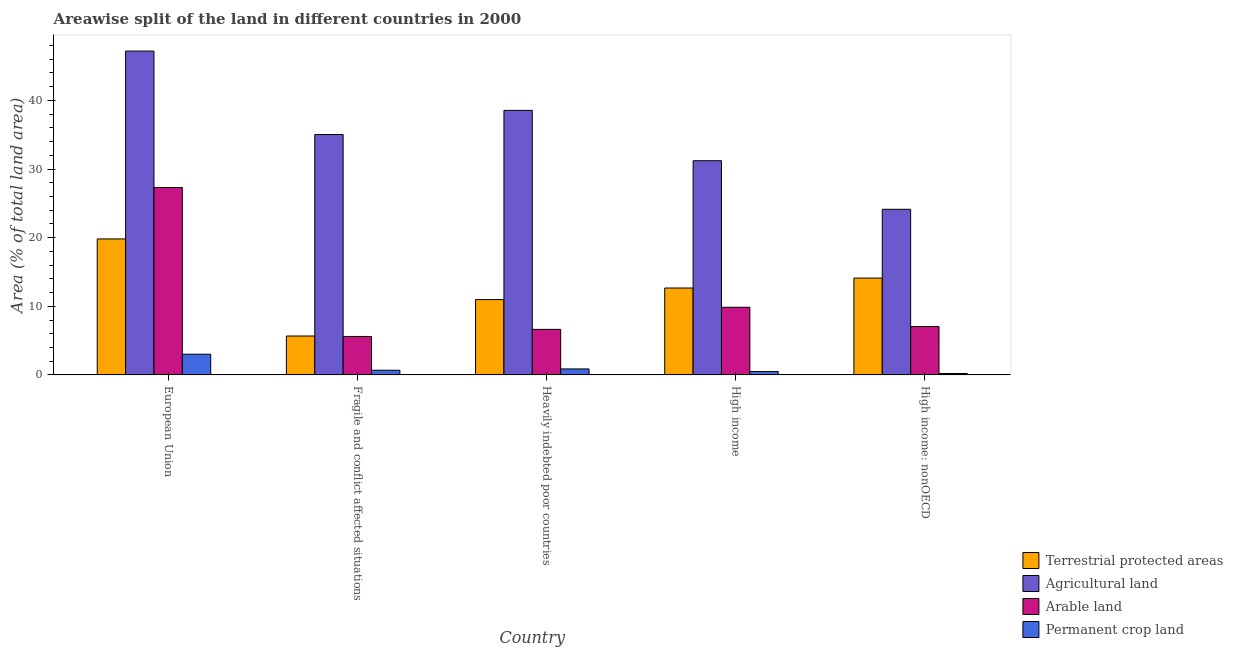How many different coloured bars are there?
Ensure brevity in your answer.  4. Are the number of bars per tick equal to the number of legend labels?
Give a very brief answer. Yes. How many bars are there on the 4th tick from the left?
Provide a succinct answer. 4. How many bars are there on the 3rd tick from the right?
Provide a succinct answer. 4. What is the percentage of area under agricultural land in European Union?
Offer a terse response. 47.19. Across all countries, what is the maximum percentage of area under agricultural land?
Provide a succinct answer. 47.19. Across all countries, what is the minimum percentage of area under permanent crop land?
Ensure brevity in your answer.  0.21. In which country was the percentage of land under terrestrial protection maximum?
Your answer should be very brief. European Union. In which country was the percentage of area under arable land minimum?
Offer a terse response. Fragile and conflict affected situations. What is the total percentage of land under terrestrial protection in the graph?
Provide a short and direct response. 63.24. What is the difference between the percentage of land under terrestrial protection in European Union and that in High income?
Offer a terse response. 7.15. What is the difference between the percentage of area under arable land in European Union and the percentage of land under terrestrial protection in High income?
Your response must be concise. 14.64. What is the average percentage of area under permanent crop land per country?
Make the answer very short. 1.05. What is the difference between the percentage of area under arable land and percentage of area under permanent crop land in Heavily indebted poor countries?
Your answer should be compact. 5.76. What is the ratio of the percentage of area under agricultural land in European Union to that in High income: nonOECD?
Give a very brief answer. 1.96. Is the difference between the percentage of area under permanent crop land in Heavily indebted poor countries and High income greater than the difference between the percentage of land under terrestrial protection in Heavily indebted poor countries and High income?
Your response must be concise. Yes. What is the difference between the highest and the second highest percentage of area under agricultural land?
Keep it short and to the point. 8.64. What is the difference between the highest and the lowest percentage of area under arable land?
Your answer should be compact. 21.71. In how many countries, is the percentage of area under arable land greater than the average percentage of area under arable land taken over all countries?
Your answer should be compact. 1. What does the 4th bar from the left in Fragile and conflict affected situations represents?
Your answer should be compact. Permanent crop land. What does the 2nd bar from the right in High income represents?
Give a very brief answer. Arable land. Is it the case that in every country, the sum of the percentage of land under terrestrial protection and percentage of area under agricultural land is greater than the percentage of area under arable land?
Provide a succinct answer. Yes. Are all the bars in the graph horizontal?
Make the answer very short. No. Are the values on the major ticks of Y-axis written in scientific E-notation?
Your response must be concise. No. Does the graph contain grids?
Your response must be concise. No. How many legend labels are there?
Make the answer very short. 4. What is the title of the graph?
Provide a succinct answer. Areawise split of the land in different countries in 2000. Does "International Development Association" appear as one of the legend labels in the graph?
Provide a succinct answer. No. What is the label or title of the X-axis?
Give a very brief answer. Country. What is the label or title of the Y-axis?
Your response must be concise. Area (% of total land area). What is the Area (% of total land area) of Terrestrial protected areas in European Union?
Offer a terse response. 19.81. What is the Area (% of total land area) in Agricultural land in European Union?
Keep it short and to the point. 47.19. What is the Area (% of total land area) of Arable land in European Union?
Your response must be concise. 27.31. What is the Area (% of total land area) in Permanent crop land in European Union?
Provide a succinct answer. 3.02. What is the Area (% of total land area) of Terrestrial protected areas in Fragile and conflict affected situations?
Your answer should be compact. 5.67. What is the Area (% of total land area) of Agricultural land in Fragile and conflict affected situations?
Keep it short and to the point. 35.03. What is the Area (% of total land area) in Arable land in Fragile and conflict affected situations?
Your answer should be compact. 5.6. What is the Area (% of total land area) of Permanent crop land in Fragile and conflict affected situations?
Give a very brief answer. 0.68. What is the Area (% of total land area) of Terrestrial protected areas in Heavily indebted poor countries?
Give a very brief answer. 10.98. What is the Area (% of total land area) in Agricultural land in Heavily indebted poor countries?
Your answer should be compact. 38.55. What is the Area (% of total land area) in Arable land in Heavily indebted poor countries?
Offer a terse response. 6.64. What is the Area (% of total land area) of Permanent crop land in Heavily indebted poor countries?
Give a very brief answer. 0.87. What is the Area (% of total land area) of Terrestrial protected areas in High income?
Provide a succinct answer. 12.67. What is the Area (% of total land area) in Agricultural land in High income?
Your answer should be compact. 31.21. What is the Area (% of total land area) of Arable land in High income?
Offer a very short reply. 9.86. What is the Area (% of total land area) of Permanent crop land in High income?
Make the answer very short. 0.5. What is the Area (% of total land area) of Terrestrial protected areas in High income: nonOECD?
Your answer should be compact. 14.11. What is the Area (% of total land area) of Agricultural land in High income: nonOECD?
Your response must be concise. 24.14. What is the Area (% of total land area) of Arable land in High income: nonOECD?
Offer a terse response. 7.05. What is the Area (% of total land area) in Permanent crop land in High income: nonOECD?
Your answer should be compact. 0.21. Across all countries, what is the maximum Area (% of total land area) of Terrestrial protected areas?
Your answer should be very brief. 19.81. Across all countries, what is the maximum Area (% of total land area) of Agricultural land?
Your answer should be very brief. 47.19. Across all countries, what is the maximum Area (% of total land area) of Arable land?
Provide a succinct answer. 27.31. Across all countries, what is the maximum Area (% of total land area) in Permanent crop land?
Make the answer very short. 3.02. Across all countries, what is the minimum Area (% of total land area) in Terrestrial protected areas?
Offer a terse response. 5.67. Across all countries, what is the minimum Area (% of total land area) of Agricultural land?
Provide a short and direct response. 24.14. Across all countries, what is the minimum Area (% of total land area) in Arable land?
Your response must be concise. 5.6. Across all countries, what is the minimum Area (% of total land area) in Permanent crop land?
Your response must be concise. 0.21. What is the total Area (% of total land area) in Terrestrial protected areas in the graph?
Your answer should be compact. 63.24. What is the total Area (% of total land area) of Agricultural land in the graph?
Offer a terse response. 176.12. What is the total Area (% of total land area) of Arable land in the graph?
Make the answer very short. 56.45. What is the total Area (% of total land area) of Permanent crop land in the graph?
Your response must be concise. 5.27. What is the difference between the Area (% of total land area) in Terrestrial protected areas in European Union and that in Fragile and conflict affected situations?
Your answer should be very brief. 14.14. What is the difference between the Area (% of total land area) in Agricultural land in European Union and that in Fragile and conflict affected situations?
Make the answer very short. 12.17. What is the difference between the Area (% of total land area) of Arable land in European Union and that in Fragile and conflict affected situations?
Keep it short and to the point. 21.71. What is the difference between the Area (% of total land area) in Permanent crop land in European Union and that in Fragile and conflict affected situations?
Give a very brief answer. 2.33. What is the difference between the Area (% of total land area) of Terrestrial protected areas in European Union and that in Heavily indebted poor countries?
Ensure brevity in your answer.  8.83. What is the difference between the Area (% of total land area) of Agricultural land in European Union and that in Heavily indebted poor countries?
Give a very brief answer. 8.64. What is the difference between the Area (% of total land area) of Arable land in European Union and that in Heavily indebted poor countries?
Offer a terse response. 20.67. What is the difference between the Area (% of total land area) of Permanent crop land in European Union and that in Heavily indebted poor countries?
Offer a very short reply. 2.14. What is the difference between the Area (% of total land area) of Terrestrial protected areas in European Union and that in High income?
Give a very brief answer. 7.15. What is the difference between the Area (% of total land area) in Agricultural land in European Union and that in High income?
Ensure brevity in your answer.  15.98. What is the difference between the Area (% of total land area) in Arable land in European Union and that in High income?
Your answer should be compact. 17.45. What is the difference between the Area (% of total land area) in Permanent crop land in European Union and that in High income?
Provide a succinct answer. 2.52. What is the difference between the Area (% of total land area) in Terrestrial protected areas in European Union and that in High income: nonOECD?
Provide a short and direct response. 5.7. What is the difference between the Area (% of total land area) in Agricultural land in European Union and that in High income: nonOECD?
Ensure brevity in your answer.  23.06. What is the difference between the Area (% of total land area) in Arable land in European Union and that in High income: nonOECD?
Provide a short and direct response. 20.26. What is the difference between the Area (% of total land area) in Permanent crop land in European Union and that in High income: nonOECD?
Give a very brief answer. 2.81. What is the difference between the Area (% of total land area) in Terrestrial protected areas in Fragile and conflict affected situations and that in Heavily indebted poor countries?
Offer a terse response. -5.31. What is the difference between the Area (% of total land area) of Agricultural land in Fragile and conflict affected situations and that in Heavily indebted poor countries?
Your response must be concise. -3.52. What is the difference between the Area (% of total land area) in Arable land in Fragile and conflict affected situations and that in Heavily indebted poor countries?
Your response must be concise. -1.03. What is the difference between the Area (% of total land area) in Permanent crop land in Fragile and conflict affected situations and that in Heavily indebted poor countries?
Offer a very short reply. -0.19. What is the difference between the Area (% of total land area) of Terrestrial protected areas in Fragile and conflict affected situations and that in High income?
Your response must be concise. -7. What is the difference between the Area (% of total land area) of Agricultural land in Fragile and conflict affected situations and that in High income?
Your response must be concise. 3.81. What is the difference between the Area (% of total land area) of Arable land in Fragile and conflict affected situations and that in High income?
Offer a terse response. -4.25. What is the difference between the Area (% of total land area) of Permanent crop land in Fragile and conflict affected situations and that in High income?
Keep it short and to the point. 0.18. What is the difference between the Area (% of total land area) in Terrestrial protected areas in Fragile and conflict affected situations and that in High income: nonOECD?
Ensure brevity in your answer.  -8.44. What is the difference between the Area (% of total land area) of Agricultural land in Fragile and conflict affected situations and that in High income: nonOECD?
Provide a short and direct response. 10.89. What is the difference between the Area (% of total land area) of Arable land in Fragile and conflict affected situations and that in High income: nonOECD?
Ensure brevity in your answer.  -1.45. What is the difference between the Area (% of total land area) of Permanent crop land in Fragile and conflict affected situations and that in High income: nonOECD?
Your answer should be compact. 0.47. What is the difference between the Area (% of total land area) in Terrestrial protected areas in Heavily indebted poor countries and that in High income?
Provide a short and direct response. -1.69. What is the difference between the Area (% of total land area) of Agricultural land in Heavily indebted poor countries and that in High income?
Give a very brief answer. 7.34. What is the difference between the Area (% of total land area) in Arable land in Heavily indebted poor countries and that in High income?
Offer a very short reply. -3.22. What is the difference between the Area (% of total land area) in Permanent crop land in Heavily indebted poor countries and that in High income?
Give a very brief answer. 0.38. What is the difference between the Area (% of total land area) of Terrestrial protected areas in Heavily indebted poor countries and that in High income: nonOECD?
Provide a short and direct response. -3.13. What is the difference between the Area (% of total land area) in Agricultural land in Heavily indebted poor countries and that in High income: nonOECD?
Ensure brevity in your answer.  14.41. What is the difference between the Area (% of total land area) in Arable land in Heavily indebted poor countries and that in High income: nonOECD?
Your answer should be compact. -0.41. What is the difference between the Area (% of total land area) of Permanent crop land in Heavily indebted poor countries and that in High income: nonOECD?
Give a very brief answer. 0.67. What is the difference between the Area (% of total land area) in Terrestrial protected areas in High income and that in High income: nonOECD?
Make the answer very short. -1.45. What is the difference between the Area (% of total land area) in Agricultural land in High income and that in High income: nonOECD?
Offer a very short reply. 7.08. What is the difference between the Area (% of total land area) of Arable land in High income and that in High income: nonOECD?
Ensure brevity in your answer.  2.81. What is the difference between the Area (% of total land area) in Permanent crop land in High income and that in High income: nonOECD?
Keep it short and to the point. 0.29. What is the difference between the Area (% of total land area) of Terrestrial protected areas in European Union and the Area (% of total land area) of Agricultural land in Fragile and conflict affected situations?
Give a very brief answer. -15.21. What is the difference between the Area (% of total land area) in Terrestrial protected areas in European Union and the Area (% of total land area) in Arable land in Fragile and conflict affected situations?
Provide a succinct answer. 14.21. What is the difference between the Area (% of total land area) in Terrestrial protected areas in European Union and the Area (% of total land area) in Permanent crop land in Fragile and conflict affected situations?
Your response must be concise. 19.13. What is the difference between the Area (% of total land area) in Agricultural land in European Union and the Area (% of total land area) in Arable land in Fragile and conflict affected situations?
Make the answer very short. 41.59. What is the difference between the Area (% of total land area) of Agricultural land in European Union and the Area (% of total land area) of Permanent crop land in Fragile and conflict affected situations?
Your response must be concise. 46.51. What is the difference between the Area (% of total land area) in Arable land in European Union and the Area (% of total land area) in Permanent crop land in Fragile and conflict affected situations?
Offer a terse response. 26.63. What is the difference between the Area (% of total land area) in Terrestrial protected areas in European Union and the Area (% of total land area) in Agricultural land in Heavily indebted poor countries?
Provide a succinct answer. -18.74. What is the difference between the Area (% of total land area) of Terrestrial protected areas in European Union and the Area (% of total land area) of Arable land in Heavily indebted poor countries?
Provide a short and direct response. 13.18. What is the difference between the Area (% of total land area) of Terrestrial protected areas in European Union and the Area (% of total land area) of Permanent crop land in Heavily indebted poor countries?
Your answer should be compact. 18.94. What is the difference between the Area (% of total land area) of Agricultural land in European Union and the Area (% of total land area) of Arable land in Heavily indebted poor countries?
Keep it short and to the point. 40.56. What is the difference between the Area (% of total land area) in Agricultural land in European Union and the Area (% of total land area) in Permanent crop land in Heavily indebted poor countries?
Give a very brief answer. 46.32. What is the difference between the Area (% of total land area) of Arable land in European Union and the Area (% of total land area) of Permanent crop land in Heavily indebted poor countries?
Your response must be concise. 26.44. What is the difference between the Area (% of total land area) of Terrestrial protected areas in European Union and the Area (% of total land area) of Agricultural land in High income?
Offer a terse response. -11.4. What is the difference between the Area (% of total land area) in Terrestrial protected areas in European Union and the Area (% of total land area) in Arable land in High income?
Keep it short and to the point. 9.96. What is the difference between the Area (% of total land area) of Terrestrial protected areas in European Union and the Area (% of total land area) of Permanent crop land in High income?
Offer a terse response. 19.32. What is the difference between the Area (% of total land area) in Agricultural land in European Union and the Area (% of total land area) in Arable land in High income?
Provide a short and direct response. 37.34. What is the difference between the Area (% of total land area) in Agricultural land in European Union and the Area (% of total land area) in Permanent crop land in High income?
Keep it short and to the point. 46.7. What is the difference between the Area (% of total land area) in Arable land in European Union and the Area (% of total land area) in Permanent crop land in High income?
Give a very brief answer. 26.81. What is the difference between the Area (% of total land area) of Terrestrial protected areas in European Union and the Area (% of total land area) of Agricultural land in High income: nonOECD?
Provide a short and direct response. -4.32. What is the difference between the Area (% of total land area) of Terrestrial protected areas in European Union and the Area (% of total land area) of Arable land in High income: nonOECD?
Give a very brief answer. 12.77. What is the difference between the Area (% of total land area) in Terrestrial protected areas in European Union and the Area (% of total land area) in Permanent crop land in High income: nonOECD?
Your response must be concise. 19.61. What is the difference between the Area (% of total land area) of Agricultural land in European Union and the Area (% of total land area) of Arable land in High income: nonOECD?
Ensure brevity in your answer.  40.14. What is the difference between the Area (% of total land area) of Agricultural land in European Union and the Area (% of total land area) of Permanent crop land in High income: nonOECD?
Your answer should be compact. 46.99. What is the difference between the Area (% of total land area) in Arable land in European Union and the Area (% of total land area) in Permanent crop land in High income: nonOECD?
Make the answer very short. 27.1. What is the difference between the Area (% of total land area) of Terrestrial protected areas in Fragile and conflict affected situations and the Area (% of total land area) of Agricultural land in Heavily indebted poor countries?
Your response must be concise. -32.88. What is the difference between the Area (% of total land area) in Terrestrial protected areas in Fragile and conflict affected situations and the Area (% of total land area) in Arable land in Heavily indebted poor countries?
Provide a short and direct response. -0.97. What is the difference between the Area (% of total land area) in Terrestrial protected areas in Fragile and conflict affected situations and the Area (% of total land area) in Permanent crop land in Heavily indebted poor countries?
Keep it short and to the point. 4.8. What is the difference between the Area (% of total land area) in Agricultural land in Fragile and conflict affected situations and the Area (% of total land area) in Arable land in Heavily indebted poor countries?
Your response must be concise. 28.39. What is the difference between the Area (% of total land area) in Agricultural land in Fragile and conflict affected situations and the Area (% of total land area) in Permanent crop land in Heavily indebted poor countries?
Your response must be concise. 34.16. What is the difference between the Area (% of total land area) of Arable land in Fragile and conflict affected situations and the Area (% of total land area) of Permanent crop land in Heavily indebted poor countries?
Provide a short and direct response. 4.73. What is the difference between the Area (% of total land area) in Terrestrial protected areas in Fragile and conflict affected situations and the Area (% of total land area) in Agricultural land in High income?
Give a very brief answer. -25.54. What is the difference between the Area (% of total land area) in Terrestrial protected areas in Fragile and conflict affected situations and the Area (% of total land area) in Arable land in High income?
Make the answer very short. -4.19. What is the difference between the Area (% of total land area) in Terrestrial protected areas in Fragile and conflict affected situations and the Area (% of total land area) in Permanent crop land in High income?
Provide a succinct answer. 5.17. What is the difference between the Area (% of total land area) of Agricultural land in Fragile and conflict affected situations and the Area (% of total land area) of Arable land in High income?
Provide a succinct answer. 25.17. What is the difference between the Area (% of total land area) in Agricultural land in Fragile and conflict affected situations and the Area (% of total land area) in Permanent crop land in High income?
Your response must be concise. 34.53. What is the difference between the Area (% of total land area) in Arable land in Fragile and conflict affected situations and the Area (% of total land area) in Permanent crop land in High income?
Your answer should be very brief. 5.11. What is the difference between the Area (% of total land area) of Terrestrial protected areas in Fragile and conflict affected situations and the Area (% of total land area) of Agricultural land in High income: nonOECD?
Make the answer very short. -18.47. What is the difference between the Area (% of total land area) of Terrestrial protected areas in Fragile and conflict affected situations and the Area (% of total land area) of Arable land in High income: nonOECD?
Your answer should be compact. -1.38. What is the difference between the Area (% of total land area) in Terrestrial protected areas in Fragile and conflict affected situations and the Area (% of total land area) in Permanent crop land in High income: nonOECD?
Your answer should be very brief. 5.46. What is the difference between the Area (% of total land area) in Agricultural land in Fragile and conflict affected situations and the Area (% of total land area) in Arable land in High income: nonOECD?
Offer a very short reply. 27.98. What is the difference between the Area (% of total land area) of Agricultural land in Fragile and conflict affected situations and the Area (% of total land area) of Permanent crop land in High income: nonOECD?
Your response must be concise. 34.82. What is the difference between the Area (% of total land area) in Arable land in Fragile and conflict affected situations and the Area (% of total land area) in Permanent crop land in High income: nonOECD?
Provide a succinct answer. 5.4. What is the difference between the Area (% of total land area) in Terrestrial protected areas in Heavily indebted poor countries and the Area (% of total land area) in Agricultural land in High income?
Ensure brevity in your answer.  -20.23. What is the difference between the Area (% of total land area) in Terrestrial protected areas in Heavily indebted poor countries and the Area (% of total land area) in Arable land in High income?
Make the answer very short. 1.12. What is the difference between the Area (% of total land area) of Terrestrial protected areas in Heavily indebted poor countries and the Area (% of total land area) of Permanent crop land in High income?
Offer a terse response. 10.48. What is the difference between the Area (% of total land area) of Agricultural land in Heavily indebted poor countries and the Area (% of total land area) of Arable land in High income?
Your response must be concise. 28.69. What is the difference between the Area (% of total land area) in Agricultural land in Heavily indebted poor countries and the Area (% of total land area) in Permanent crop land in High income?
Offer a very short reply. 38.05. What is the difference between the Area (% of total land area) in Arable land in Heavily indebted poor countries and the Area (% of total land area) in Permanent crop land in High income?
Make the answer very short. 6.14. What is the difference between the Area (% of total land area) of Terrestrial protected areas in Heavily indebted poor countries and the Area (% of total land area) of Agricultural land in High income: nonOECD?
Your response must be concise. -13.16. What is the difference between the Area (% of total land area) in Terrestrial protected areas in Heavily indebted poor countries and the Area (% of total land area) in Arable land in High income: nonOECD?
Your answer should be compact. 3.93. What is the difference between the Area (% of total land area) of Terrestrial protected areas in Heavily indebted poor countries and the Area (% of total land area) of Permanent crop land in High income: nonOECD?
Provide a short and direct response. 10.77. What is the difference between the Area (% of total land area) in Agricultural land in Heavily indebted poor countries and the Area (% of total land area) in Arable land in High income: nonOECD?
Your answer should be compact. 31.5. What is the difference between the Area (% of total land area) in Agricultural land in Heavily indebted poor countries and the Area (% of total land area) in Permanent crop land in High income: nonOECD?
Provide a short and direct response. 38.34. What is the difference between the Area (% of total land area) in Arable land in Heavily indebted poor countries and the Area (% of total land area) in Permanent crop land in High income: nonOECD?
Make the answer very short. 6.43. What is the difference between the Area (% of total land area) in Terrestrial protected areas in High income and the Area (% of total land area) in Agricultural land in High income: nonOECD?
Provide a short and direct response. -11.47. What is the difference between the Area (% of total land area) of Terrestrial protected areas in High income and the Area (% of total land area) of Arable land in High income: nonOECD?
Keep it short and to the point. 5.62. What is the difference between the Area (% of total land area) of Terrestrial protected areas in High income and the Area (% of total land area) of Permanent crop land in High income: nonOECD?
Your response must be concise. 12.46. What is the difference between the Area (% of total land area) of Agricultural land in High income and the Area (% of total land area) of Arable land in High income: nonOECD?
Your answer should be very brief. 24.16. What is the difference between the Area (% of total land area) of Agricultural land in High income and the Area (% of total land area) of Permanent crop land in High income: nonOECD?
Offer a terse response. 31.01. What is the difference between the Area (% of total land area) in Arable land in High income and the Area (% of total land area) in Permanent crop land in High income: nonOECD?
Give a very brief answer. 9.65. What is the average Area (% of total land area) of Terrestrial protected areas per country?
Make the answer very short. 12.65. What is the average Area (% of total land area) in Agricultural land per country?
Provide a succinct answer. 35.22. What is the average Area (% of total land area) of Arable land per country?
Your answer should be compact. 11.29. What is the average Area (% of total land area) of Permanent crop land per country?
Your answer should be compact. 1.05. What is the difference between the Area (% of total land area) of Terrestrial protected areas and Area (% of total land area) of Agricultural land in European Union?
Provide a short and direct response. -27.38. What is the difference between the Area (% of total land area) of Terrestrial protected areas and Area (% of total land area) of Arable land in European Union?
Make the answer very short. -7.49. What is the difference between the Area (% of total land area) of Terrestrial protected areas and Area (% of total land area) of Permanent crop land in European Union?
Your answer should be compact. 16.8. What is the difference between the Area (% of total land area) in Agricultural land and Area (% of total land area) in Arable land in European Union?
Your answer should be compact. 19.89. What is the difference between the Area (% of total land area) of Agricultural land and Area (% of total land area) of Permanent crop land in European Union?
Ensure brevity in your answer.  44.18. What is the difference between the Area (% of total land area) of Arable land and Area (% of total land area) of Permanent crop land in European Union?
Provide a succinct answer. 24.29. What is the difference between the Area (% of total land area) in Terrestrial protected areas and Area (% of total land area) in Agricultural land in Fragile and conflict affected situations?
Provide a succinct answer. -29.36. What is the difference between the Area (% of total land area) in Terrestrial protected areas and Area (% of total land area) in Arable land in Fragile and conflict affected situations?
Your answer should be very brief. 0.07. What is the difference between the Area (% of total land area) of Terrestrial protected areas and Area (% of total land area) of Permanent crop land in Fragile and conflict affected situations?
Ensure brevity in your answer.  4.99. What is the difference between the Area (% of total land area) in Agricultural land and Area (% of total land area) in Arable land in Fragile and conflict affected situations?
Your answer should be compact. 29.42. What is the difference between the Area (% of total land area) of Agricultural land and Area (% of total land area) of Permanent crop land in Fragile and conflict affected situations?
Your answer should be compact. 34.35. What is the difference between the Area (% of total land area) of Arable land and Area (% of total land area) of Permanent crop land in Fragile and conflict affected situations?
Keep it short and to the point. 4.92. What is the difference between the Area (% of total land area) of Terrestrial protected areas and Area (% of total land area) of Agricultural land in Heavily indebted poor countries?
Make the answer very short. -27.57. What is the difference between the Area (% of total land area) of Terrestrial protected areas and Area (% of total land area) of Arable land in Heavily indebted poor countries?
Provide a short and direct response. 4.34. What is the difference between the Area (% of total land area) in Terrestrial protected areas and Area (% of total land area) in Permanent crop land in Heavily indebted poor countries?
Provide a succinct answer. 10.11. What is the difference between the Area (% of total land area) of Agricultural land and Area (% of total land area) of Arable land in Heavily indebted poor countries?
Provide a succinct answer. 31.91. What is the difference between the Area (% of total land area) in Agricultural land and Area (% of total land area) in Permanent crop land in Heavily indebted poor countries?
Your answer should be compact. 37.68. What is the difference between the Area (% of total land area) in Arable land and Area (% of total land area) in Permanent crop land in Heavily indebted poor countries?
Offer a terse response. 5.76. What is the difference between the Area (% of total land area) of Terrestrial protected areas and Area (% of total land area) of Agricultural land in High income?
Your answer should be compact. -18.55. What is the difference between the Area (% of total land area) of Terrestrial protected areas and Area (% of total land area) of Arable land in High income?
Your answer should be very brief. 2.81. What is the difference between the Area (% of total land area) of Terrestrial protected areas and Area (% of total land area) of Permanent crop land in High income?
Offer a terse response. 12.17. What is the difference between the Area (% of total land area) in Agricultural land and Area (% of total land area) in Arable land in High income?
Make the answer very short. 21.36. What is the difference between the Area (% of total land area) of Agricultural land and Area (% of total land area) of Permanent crop land in High income?
Make the answer very short. 30.72. What is the difference between the Area (% of total land area) in Arable land and Area (% of total land area) in Permanent crop land in High income?
Give a very brief answer. 9.36. What is the difference between the Area (% of total land area) in Terrestrial protected areas and Area (% of total land area) in Agricultural land in High income: nonOECD?
Ensure brevity in your answer.  -10.02. What is the difference between the Area (% of total land area) in Terrestrial protected areas and Area (% of total land area) in Arable land in High income: nonOECD?
Ensure brevity in your answer.  7.06. What is the difference between the Area (% of total land area) of Terrestrial protected areas and Area (% of total land area) of Permanent crop land in High income: nonOECD?
Ensure brevity in your answer.  13.91. What is the difference between the Area (% of total land area) in Agricultural land and Area (% of total land area) in Arable land in High income: nonOECD?
Provide a short and direct response. 17.09. What is the difference between the Area (% of total land area) of Agricultural land and Area (% of total land area) of Permanent crop land in High income: nonOECD?
Your response must be concise. 23.93. What is the difference between the Area (% of total land area) of Arable land and Area (% of total land area) of Permanent crop land in High income: nonOECD?
Give a very brief answer. 6.84. What is the ratio of the Area (% of total land area) of Terrestrial protected areas in European Union to that in Fragile and conflict affected situations?
Ensure brevity in your answer.  3.49. What is the ratio of the Area (% of total land area) of Agricultural land in European Union to that in Fragile and conflict affected situations?
Ensure brevity in your answer.  1.35. What is the ratio of the Area (% of total land area) in Arable land in European Union to that in Fragile and conflict affected situations?
Provide a succinct answer. 4.87. What is the ratio of the Area (% of total land area) of Permanent crop land in European Union to that in Fragile and conflict affected situations?
Your response must be concise. 4.43. What is the ratio of the Area (% of total land area) of Terrestrial protected areas in European Union to that in Heavily indebted poor countries?
Provide a short and direct response. 1.8. What is the ratio of the Area (% of total land area) in Agricultural land in European Union to that in Heavily indebted poor countries?
Your response must be concise. 1.22. What is the ratio of the Area (% of total land area) in Arable land in European Union to that in Heavily indebted poor countries?
Offer a terse response. 4.12. What is the ratio of the Area (% of total land area) of Permanent crop land in European Union to that in Heavily indebted poor countries?
Provide a succinct answer. 3.46. What is the ratio of the Area (% of total land area) in Terrestrial protected areas in European Union to that in High income?
Ensure brevity in your answer.  1.56. What is the ratio of the Area (% of total land area) in Agricultural land in European Union to that in High income?
Your answer should be very brief. 1.51. What is the ratio of the Area (% of total land area) of Arable land in European Union to that in High income?
Offer a terse response. 2.77. What is the ratio of the Area (% of total land area) in Permanent crop land in European Union to that in High income?
Your response must be concise. 6.09. What is the ratio of the Area (% of total land area) in Terrestrial protected areas in European Union to that in High income: nonOECD?
Offer a terse response. 1.4. What is the ratio of the Area (% of total land area) of Agricultural land in European Union to that in High income: nonOECD?
Your answer should be compact. 1.96. What is the ratio of the Area (% of total land area) in Arable land in European Union to that in High income: nonOECD?
Offer a very short reply. 3.87. What is the ratio of the Area (% of total land area) of Permanent crop land in European Union to that in High income: nonOECD?
Your answer should be compact. 14.63. What is the ratio of the Area (% of total land area) of Terrestrial protected areas in Fragile and conflict affected situations to that in Heavily indebted poor countries?
Your answer should be compact. 0.52. What is the ratio of the Area (% of total land area) of Agricultural land in Fragile and conflict affected situations to that in Heavily indebted poor countries?
Offer a very short reply. 0.91. What is the ratio of the Area (% of total land area) in Arable land in Fragile and conflict affected situations to that in Heavily indebted poor countries?
Offer a very short reply. 0.84. What is the ratio of the Area (% of total land area) in Permanent crop land in Fragile and conflict affected situations to that in Heavily indebted poor countries?
Your answer should be compact. 0.78. What is the ratio of the Area (% of total land area) of Terrestrial protected areas in Fragile and conflict affected situations to that in High income?
Your answer should be compact. 0.45. What is the ratio of the Area (% of total land area) of Agricultural land in Fragile and conflict affected situations to that in High income?
Your answer should be very brief. 1.12. What is the ratio of the Area (% of total land area) in Arable land in Fragile and conflict affected situations to that in High income?
Offer a terse response. 0.57. What is the ratio of the Area (% of total land area) of Permanent crop land in Fragile and conflict affected situations to that in High income?
Offer a very short reply. 1.37. What is the ratio of the Area (% of total land area) in Terrestrial protected areas in Fragile and conflict affected situations to that in High income: nonOECD?
Give a very brief answer. 0.4. What is the ratio of the Area (% of total land area) in Agricultural land in Fragile and conflict affected situations to that in High income: nonOECD?
Your answer should be compact. 1.45. What is the ratio of the Area (% of total land area) of Arable land in Fragile and conflict affected situations to that in High income: nonOECD?
Offer a terse response. 0.79. What is the ratio of the Area (% of total land area) of Permanent crop land in Fragile and conflict affected situations to that in High income: nonOECD?
Provide a succinct answer. 3.3. What is the ratio of the Area (% of total land area) of Terrestrial protected areas in Heavily indebted poor countries to that in High income?
Offer a terse response. 0.87. What is the ratio of the Area (% of total land area) in Agricultural land in Heavily indebted poor countries to that in High income?
Keep it short and to the point. 1.24. What is the ratio of the Area (% of total land area) of Arable land in Heavily indebted poor countries to that in High income?
Keep it short and to the point. 0.67. What is the ratio of the Area (% of total land area) in Permanent crop land in Heavily indebted poor countries to that in High income?
Your answer should be compact. 1.76. What is the ratio of the Area (% of total land area) of Terrestrial protected areas in Heavily indebted poor countries to that in High income: nonOECD?
Provide a succinct answer. 0.78. What is the ratio of the Area (% of total land area) in Agricultural land in Heavily indebted poor countries to that in High income: nonOECD?
Keep it short and to the point. 1.6. What is the ratio of the Area (% of total land area) of Arable land in Heavily indebted poor countries to that in High income: nonOECD?
Provide a succinct answer. 0.94. What is the ratio of the Area (% of total land area) in Permanent crop land in Heavily indebted poor countries to that in High income: nonOECD?
Provide a short and direct response. 4.23. What is the ratio of the Area (% of total land area) of Terrestrial protected areas in High income to that in High income: nonOECD?
Your answer should be compact. 0.9. What is the ratio of the Area (% of total land area) in Agricultural land in High income to that in High income: nonOECD?
Provide a succinct answer. 1.29. What is the ratio of the Area (% of total land area) of Arable land in High income to that in High income: nonOECD?
Offer a very short reply. 1.4. What is the ratio of the Area (% of total land area) of Permanent crop land in High income to that in High income: nonOECD?
Make the answer very short. 2.4. What is the difference between the highest and the second highest Area (% of total land area) of Terrestrial protected areas?
Provide a short and direct response. 5.7. What is the difference between the highest and the second highest Area (% of total land area) in Agricultural land?
Your answer should be very brief. 8.64. What is the difference between the highest and the second highest Area (% of total land area) in Arable land?
Your answer should be very brief. 17.45. What is the difference between the highest and the second highest Area (% of total land area) of Permanent crop land?
Offer a terse response. 2.14. What is the difference between the highest and the lowest Area (% of total land area) in Terrestrial protected areas?
Give a very brief answer. 14.14. What is the difference between the highest and the lowest Area (% of total land area) in Agricultural land?
Your answer should be very brief. 23.06. What is the difference between the highest and the lowest Area (% of total land area) of Arable land?
Give a very brief answer. 21.71. What is the difference between the highest and the lowest Area (% of total land area) of Permanent crop land?
Your answer should be compact. 2.81. 